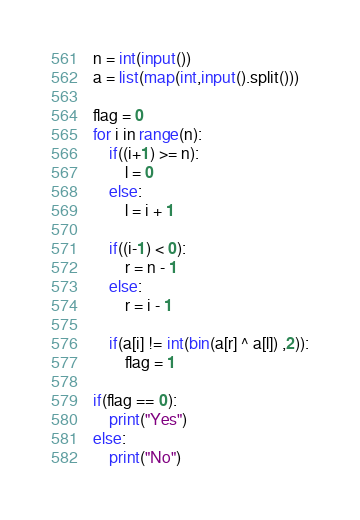<code> <loc_0><loc_0><loc_500><loc_500><_Python_>n = int(input())
a = list(map(int,input().split()))

flag = 0
for i in range(n):
    if((i+1) >= n):
        l = 0
    else:
        l = i + 1
        
    if((i-1) < 0):
        r = n - 1
    else:
        r = i - 1
    
    if(a[i] != int(bin(a[r] ^ a[l]) ,2)):
        flag = 1
        
if(flag == 0):
    print("Yes")
else:
    print("No")</code> 